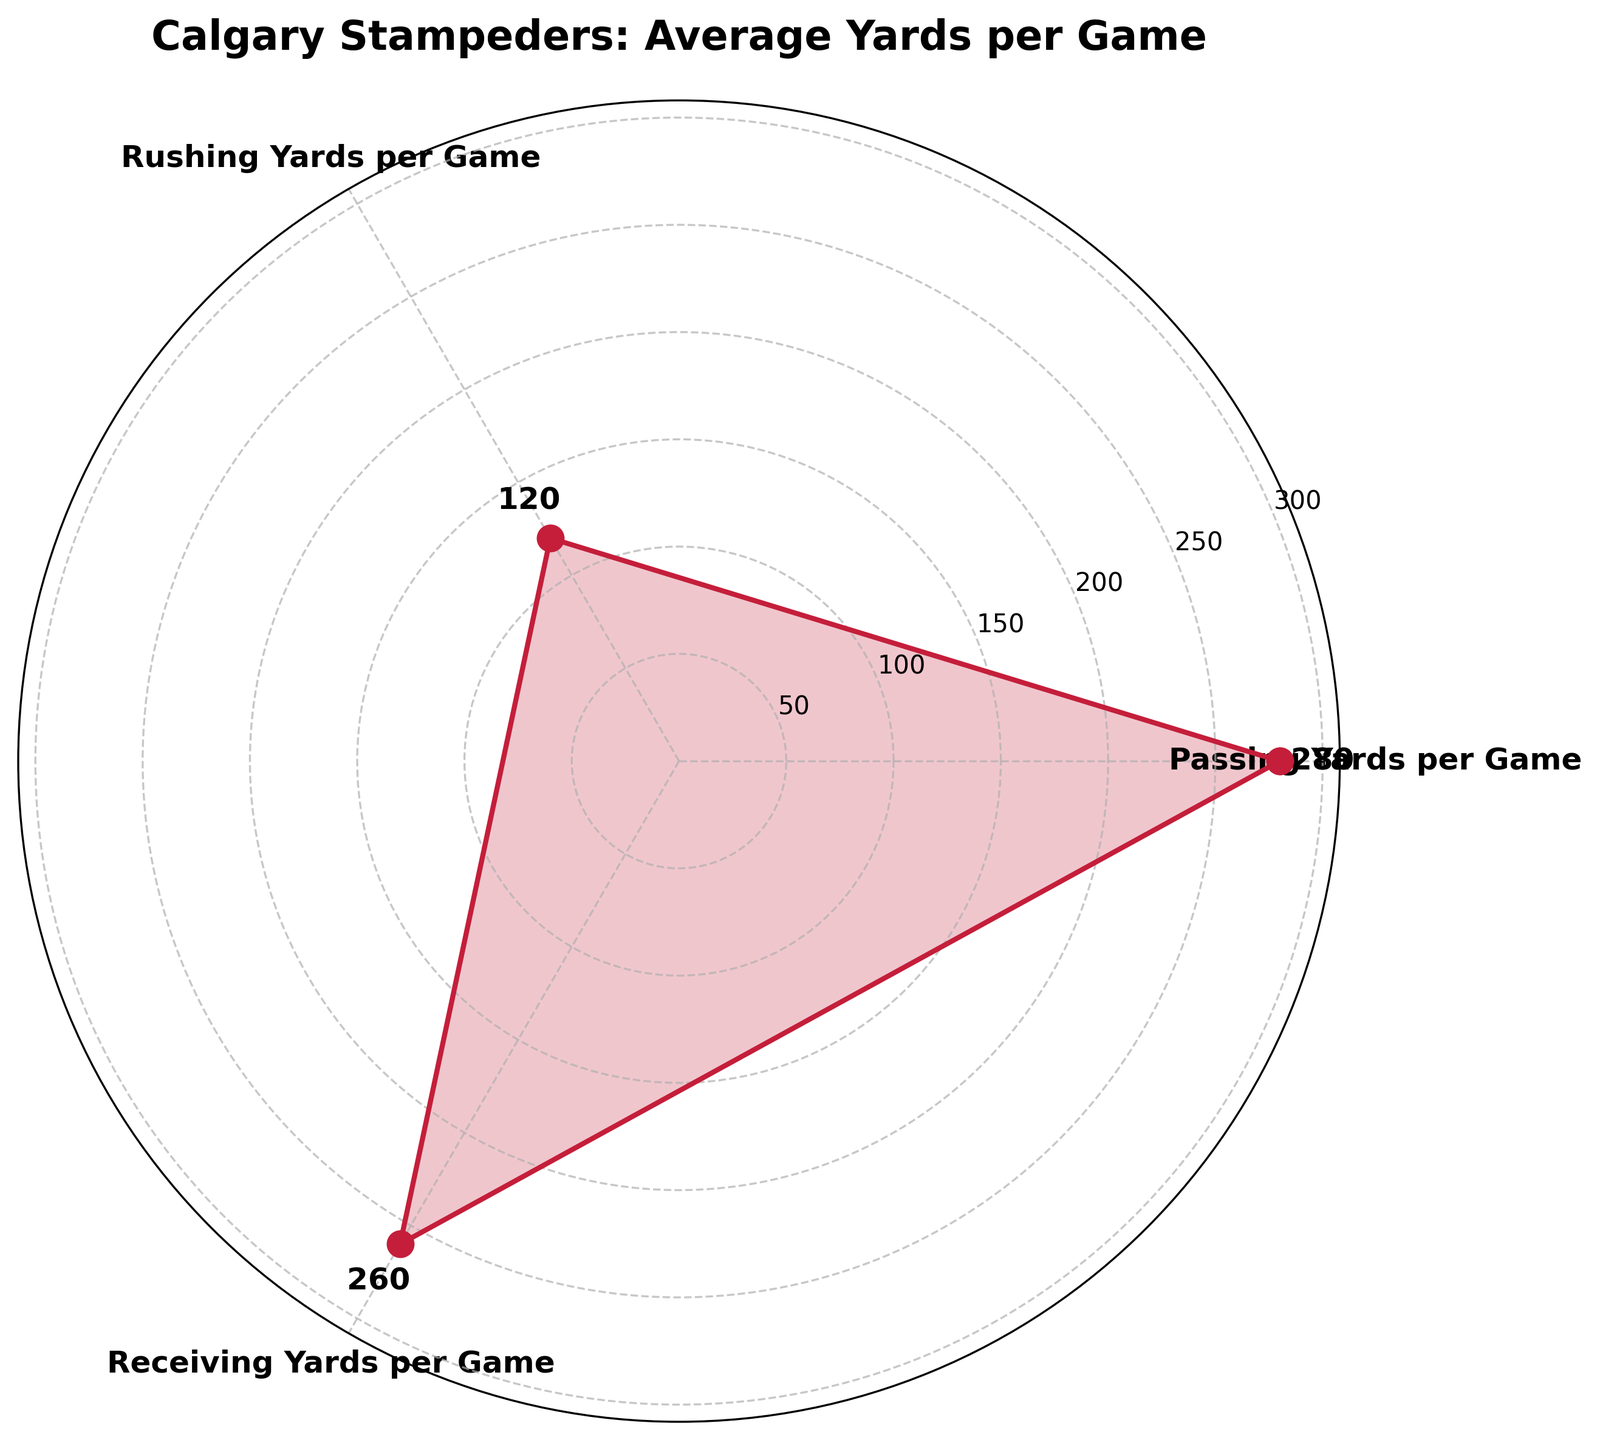What's the average passing yards per game for the Calgary Stampeders? The label on the rose chart shows the average passing yards per game at 280 yards. This value is indicated by the data point on the radial axis related to "Passing Yards per Game."
Answer: 280 yards Which category has the highest average yards per game? By looking at the radial extent of the segments, "Passing Yards per Game" and "Receiving Yards per Game" categories reach the furthest on the chart. At 280 and 260 yards respectively, the highest value can be verified as 280 yards.
Answer: Passing Yards per Game What's the combined total of rushing and receiving yards per game? The average rushing yards per game are 120 yards, and the receiving yards per game are 260 yards. Summing these two values provides the combined total as 120 + 260 = 380 yards.
Answer: 380 yards By how many yards do passing yards per game exceed rushing yards per game? The average passing yards per game are 280 yards, and the average rushing yards per game are 120 yards. The difference is calculated as 280 - 120 = 160 yards.
Answer: 160 yards Are the average rushing yards per game greater or less than the average receiving yards per game? Comparing the values, "Rushing Yards per Game" (120 yards) is less than "Receiving Yards per Game" (260 yards).
Answer: Less What is the average of the rushing yards and receiving yards per game? To find the average, add the average rushing yards (120) and receiving yards (260) and divide by two: (120 + 260) / 2 = 190 yards.
Answer: 190 yards What pattern do you observe if you compare the data points visually on the rose chart? On the rose chart, the segments form a large, generally consistent pattern with "Passing Yards per Game" and "Receiving Yards per Game" reaching higher on the radial axis than "Rushing Yards per Game," indicating higher average yards for passing and receiving compared to rushing.
Answer: Higher in passing and receiving Which two categories have the closest average yards per game values? "Passing Yards per Game" with 280 yards and "Receiving Yards per Game" with 260 yards are the closest in terms of value, differing by only 20 yards.
Answer: Passing and Receiving Yards What's the range of the average yards per game for the Calgary Stampeders? The range is the difference between the highest and lowest values. The highest is "Passing Yards per Game" at 280 yards and the lowest is "Rushing Yards per Game" at 120 yards: 280 - 120 = 160 yards.
Answer: 160 yards What's the mean average yards per game across passing, rushing, and receiving? To calculate the mean, sum all the averages (280 + 120 + 260) and divide by the number of categories (3): (280 + 120 + 260) / 3 = 220 yards per game.
Answer: 220 yards per game 